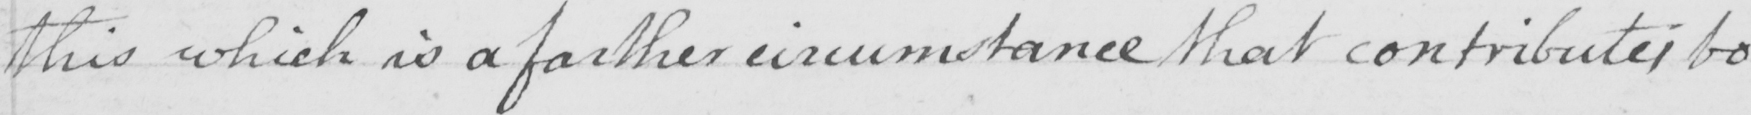Please transcribe the handwritten text in this image. this which is a farther circumstance that contibutes to 